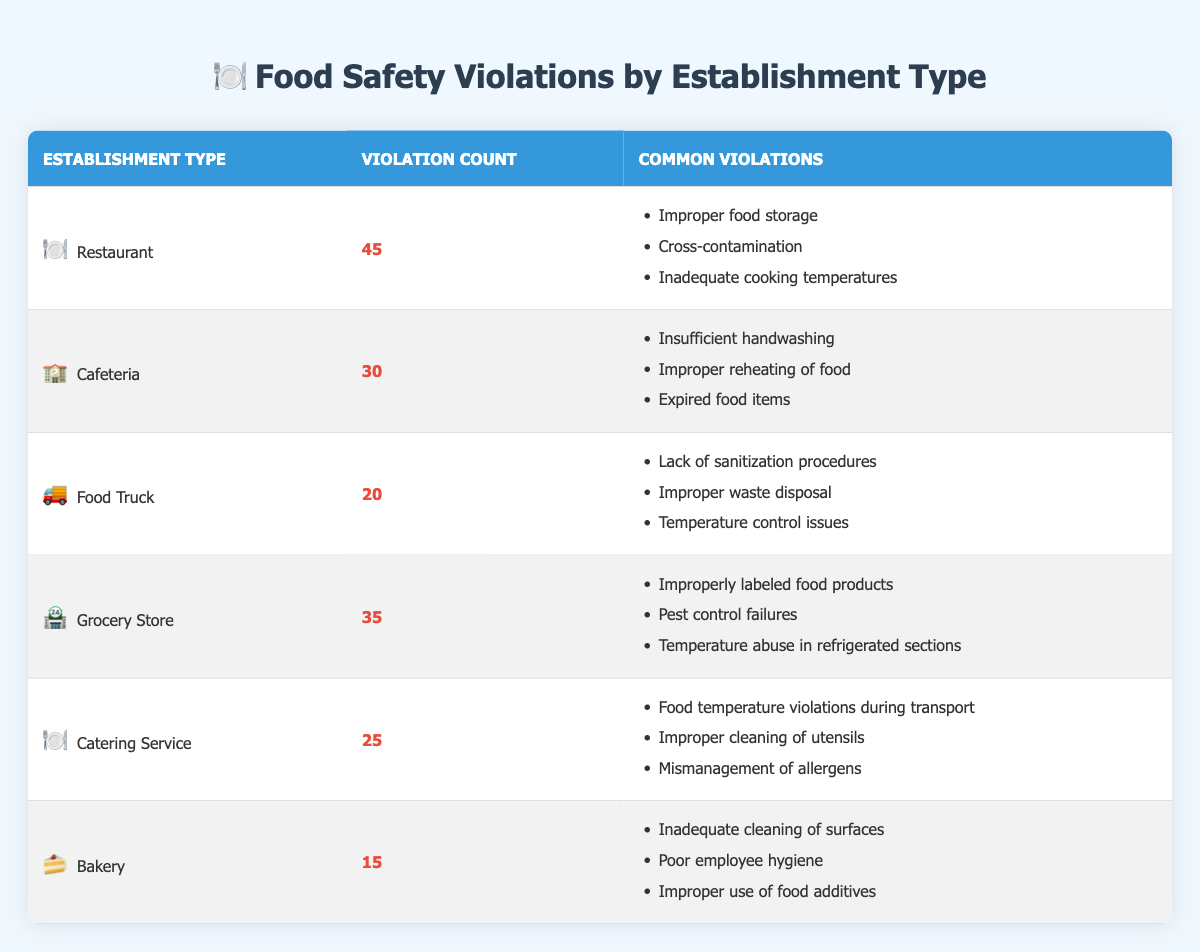What establishment type has the highest number of food safety violations? By looking at the violation counts in the table, the Restaurant has the highest number of violations with a count of 45.
Answer: Restaurant How many total food safety violations are recorded across all establishment types? The total violation count is calculated by adding the individual counts: 45 + 30 + 20 + 35 + 25 + 15 = 170.
Answer: 170 Is "Improper food storage" a common violation for Cafeterias? "Improper food storage" is listed as a common violation for Restaurants, not Cafeterias, which lists "Insufficient handwashing" as a common violation instead.
Answer: No Which establishment type has the lowest number of violations, and what is that count? By reviewing the violation counts, Bakery has the lowest count with 15 violations.
Answer: Bakery, 15 What is the average number of violations for all establishment types? To find the average, add the total violations (170) and divide by the number of establishment types (6): 170 / 6 ≈ 28.33.
Answer: Approximately 28.33 How many types of establishments have more than 25 violations? Based on the table, four establishment types—Restaurant (45), Grocery Store (35), Cafeteria (30), and Catering Service (25)—have more than 25 violations.
Answer: Four Are there more violations attributed to Food Trucks or Caterers? Food Trucks have 20 violations, while Catering Services have 25 violations. Therefore, Caterers have more violations than Food Trucks.
Answer: Caterers Focus on the most common violations across all types of establishments. What are they? Analyzing the common violations: "Improper food storage" for Restaurants, "Insufficient handwashing" for Cafeterias, "Lack of sanitization procedures" for Food Trucks, "Improperly labeled food products" for Grocery Stores, "Food temperature violations during transport" for Catering Services, and "Inadequate cleaning of surfaces" for Bakeries; no single violation is repeated across more than one type.
Answer: No repeated common violations 